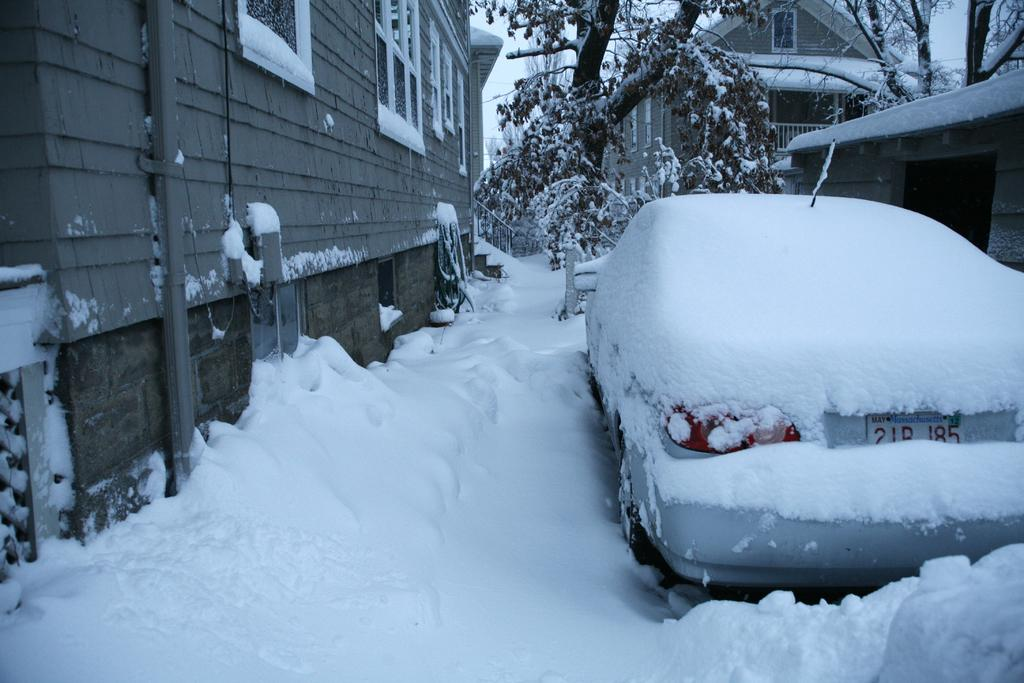What is the main subject of the image? The main subject of the image is a car. What is the weather condition in the image? There is snow in the image. Are there any structures or buildings near the car? Yes, there are houses near the car. What type of vegetation can be seen in the image? There are trees in the image. What type of scarf is the farmer wearing while playing the guitar in the image? There is no farmer, scarf, or guitar present in the image; it features a car in the snow with nearby houses and trees. 